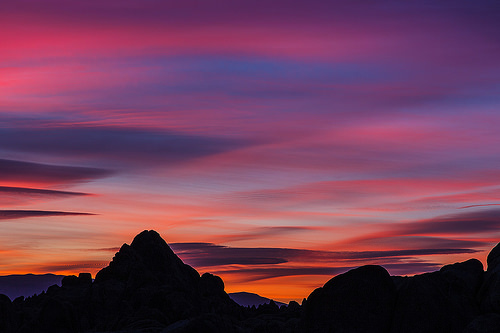<image>
Can you confirm if the sunset is behind the mountains? Yes. From this viewpoint, the sunset is positioned behind the mountains, with the mountains partially or fully occluding the sunset. 